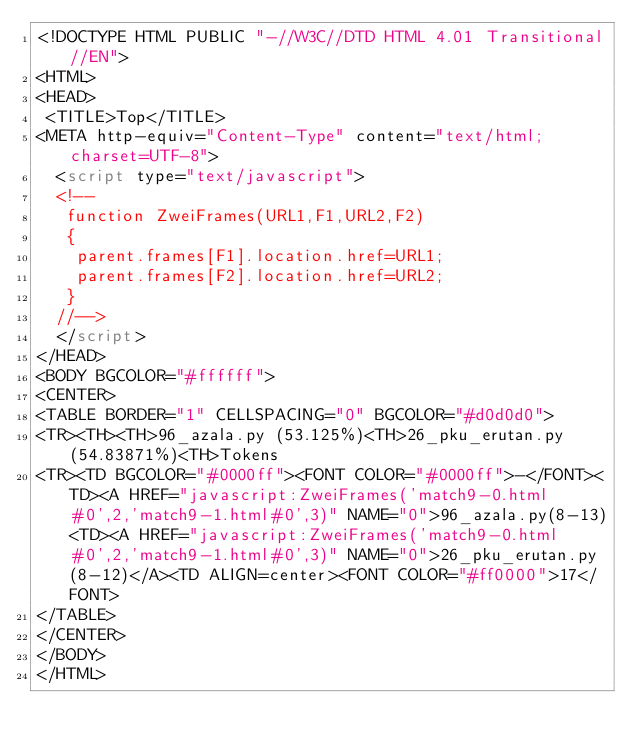<code> <loc_0><loc_0><loc_500><loc_500><_HTML_><!DOCTYPE HTML PUBLIC "-//W3C//DTD HTML 4.01 Transitional//EN">
<HTML>
<HEAD>
 <TITLE>Top</TITLE>
<META http-equiv="Content-Type" content="text/html; charset=UTF-8">
  <script type="text/javascript">
  <!--
   function ZweiFrames(URL1,F1,URL2,F2)
   {
    parent.frames[F1].location.href=URL1;
    parent.frames[F2].location.href=URL2;
   }
  //-->
  </script>
</HEAD>
<BODY BGCOLOR="#ffffff">
<CENTER>
<TABLE BORDER="1" CELLSPACING="0" BGCOLOR="#d0d0d0">
<TR><TH><TH>96_azala.py (53.125%)<TH>26_pku_erutan.py (54.83871%)<TH>Tokens
<TR><TD BGCOLOR="#0000ff"><FONT COLOR="#0000ff">-</FONT><TD><A HREF="javascript:ZweiFrames('match9-0.html#0',2,'match9-1.html#0',3)" NAME="0">96_azala.py(8-13)<TD><A HREF="javascript:ZweiFrames('match9-0.html#0',2,'match9-1.html#0',3)" NAME="0">26_pku_erutan.py(8-12)</A><TD ALIGN=center><FONT COLOR="#ff0000">17</FONT>
</TABLE>
</CENTER>
</BODY>
</HTML>

</code> 